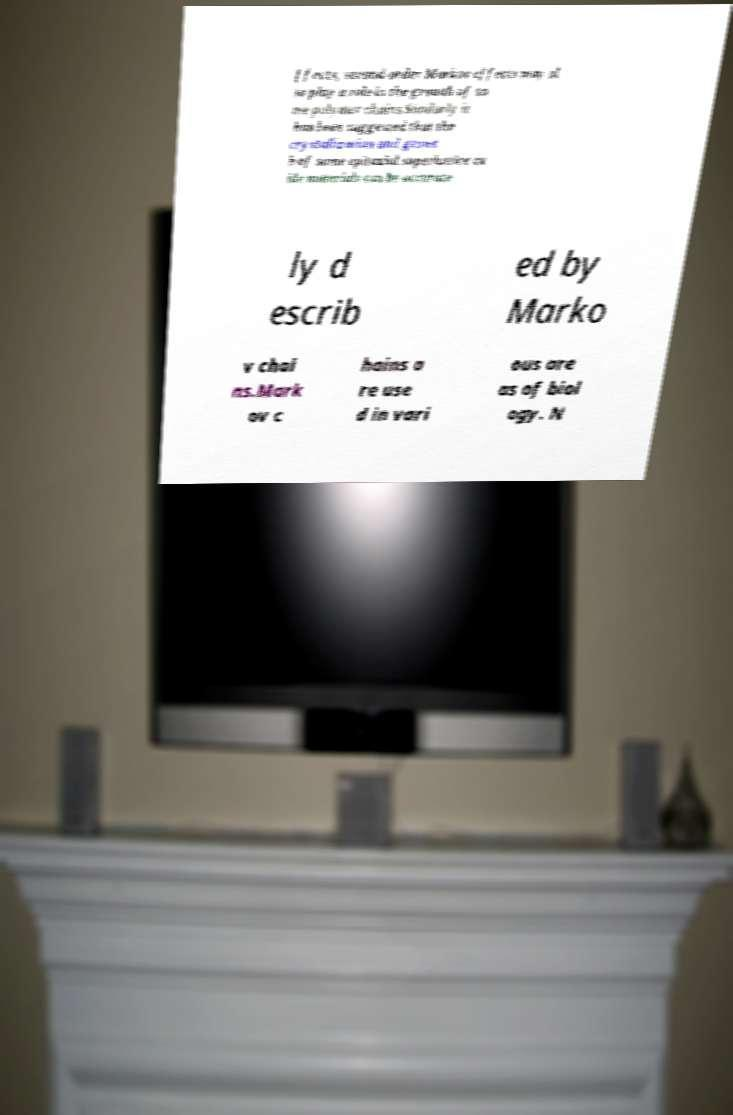Could you assist in decoding the text presented in this image and type it out clearly? ffects, second-order Markov effects may al so play a role in the growth of so me polymer chains.Similarly it has been suggested that the crystallization and growt h of some epitaxial superlattice ox ide materials can be accurate ly d escrib ed by Marko v chai ns.Mark ov c hains a re use d in vari ous are as of biol ogy. N 